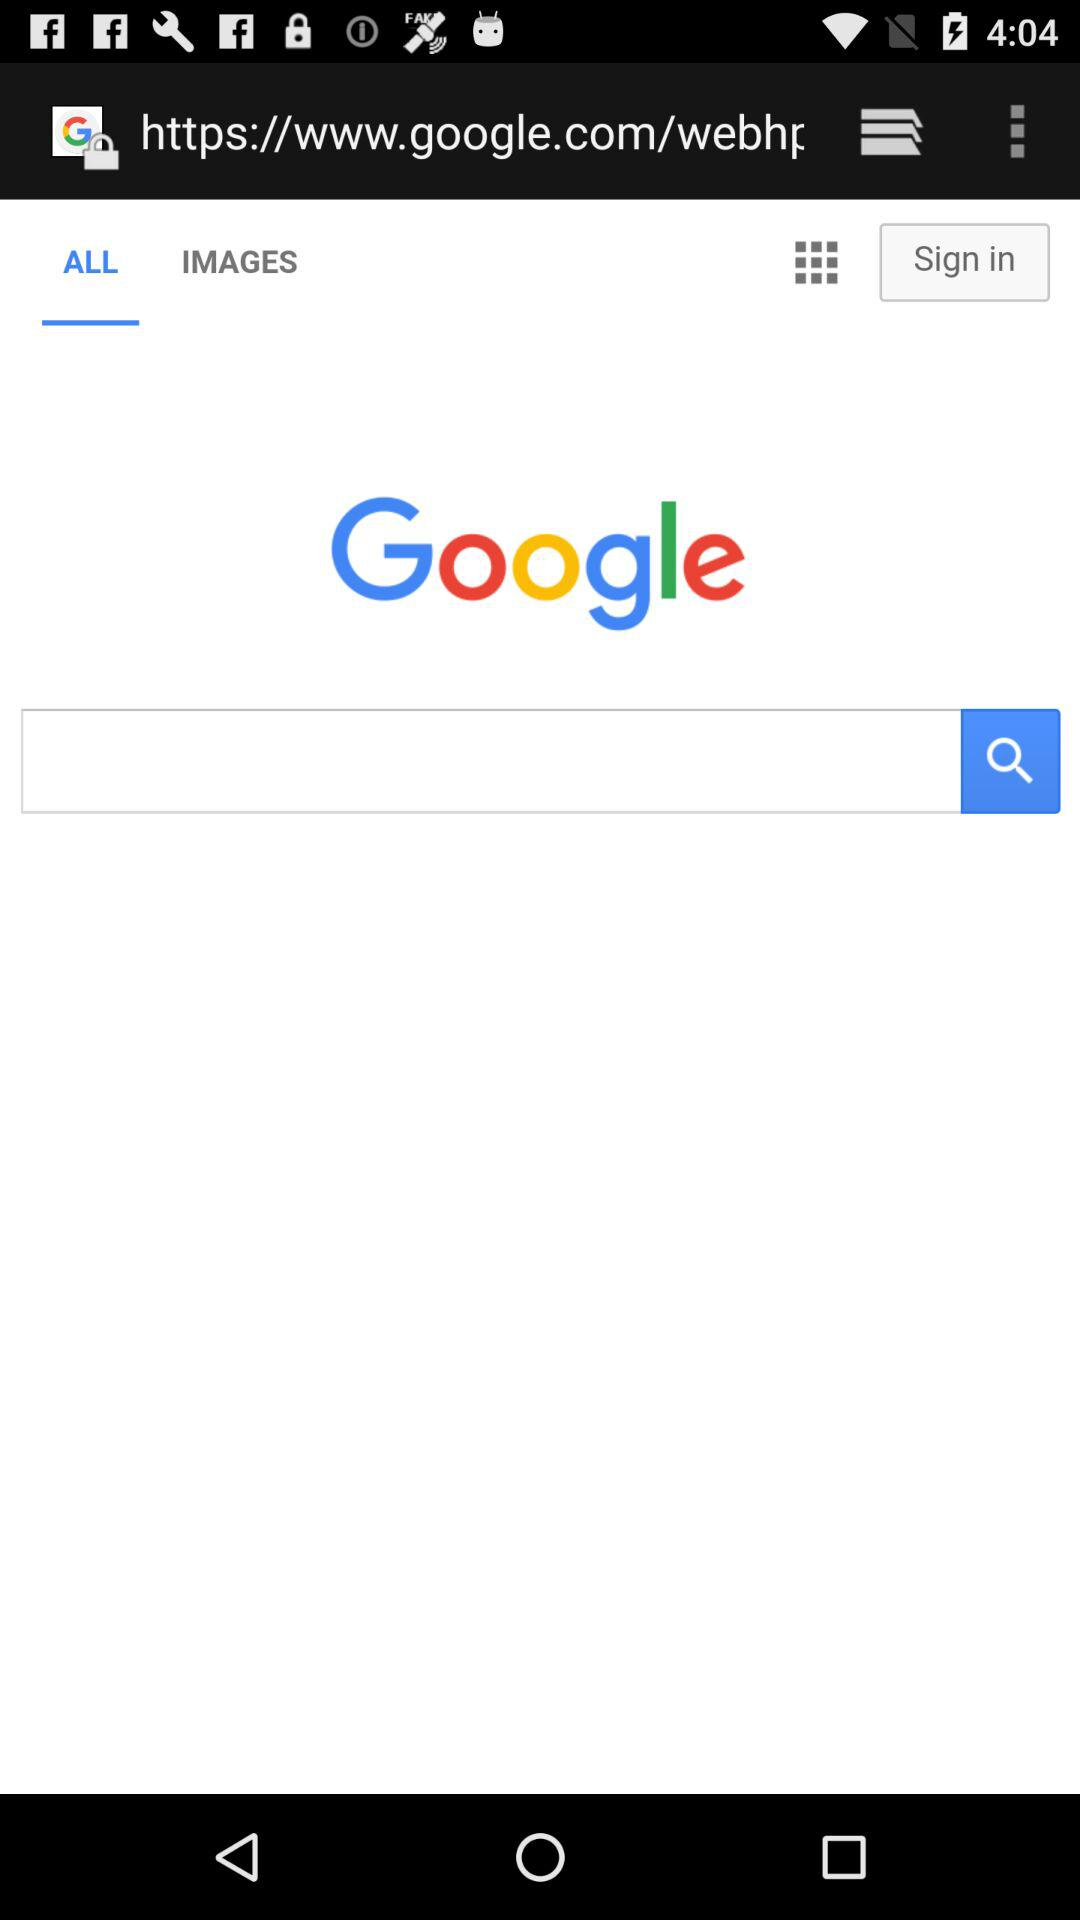What is the email address?
When the provided information is insufficient, respond with <no answer>. <no answer> 